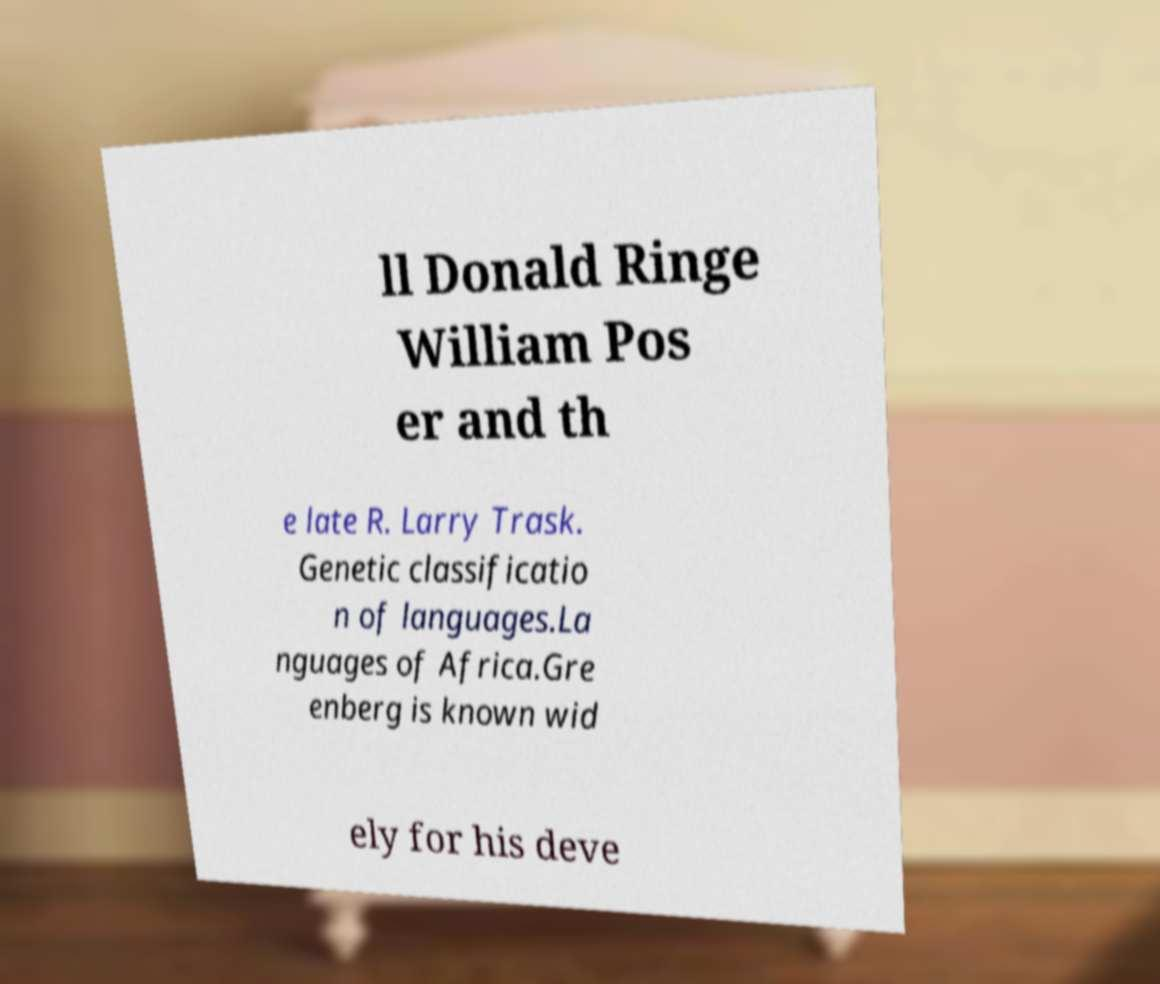I need the written content from this picture converted into text. Can you do that? ll Donald Ringe William Pos er and th e late R. Larry Trask. Genetic classificatio n of languages.La nguages of Africa.Gre enberg is known wid ely for his deve 